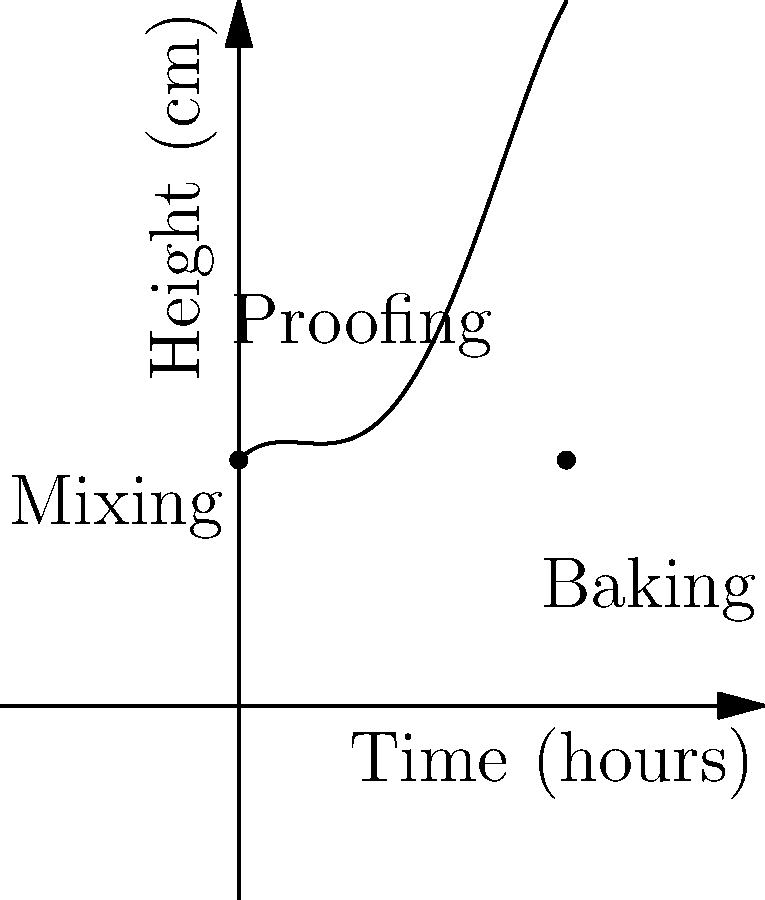As a baker-in-training, you're studying the rise and fall of bread dough during the proofing and baking process. The graph shows the height of the dough over time, represented by the polynomial function $f(x) = -0.1x^4 + 0.8x^3 - 1.5x^2 + x + 3$, where $x$ is time in hours and $f(x)$ is height in centimeters. At what time does the dough reach its maximum height? To find the maximum height of the dough, we need to follow these steps:

1) The maximum height occurs at the highest point of the curve, which is where the slope (derivative) of the function is zero.

2) Let's find the derivative of $f(x)$:
   $f'(x) = -0.4x^3 + 2.4x^2 - 3x + 1$

3) Set the derivative equal to zero:
   $-0.4x^3 + 2.4x^2 - 3x + 1 = 0$

4) This is a cubic equation. It's difficult to solve by hand, so we would typically use a graphing calculator or computer software to find the roots.

5) Using such a tool, we find that this equation has three roots: approximately 0.5, 1.5, and 3.5.

6) By looking at the graph, we can see that the maximum occurs around x = 1.5, which corresponds to the peak of the "Proofing" phase.

7) Therefore, the dough reaches its maximum height after approximately 1.5 hours.
Answer: 1.5 hours 